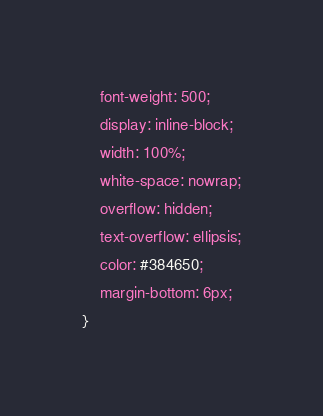<code> <loc_0><loc_0><loc_500><loc_500><_CSS_>    font-weight: 500;
    display: inline-block;
    width: 100%;
    white-space: nowrap;
    overflow: hidden;
    text-overflow: ellipsis;
    color: #384650;
    margin-bottom: 6px;
}</code> 